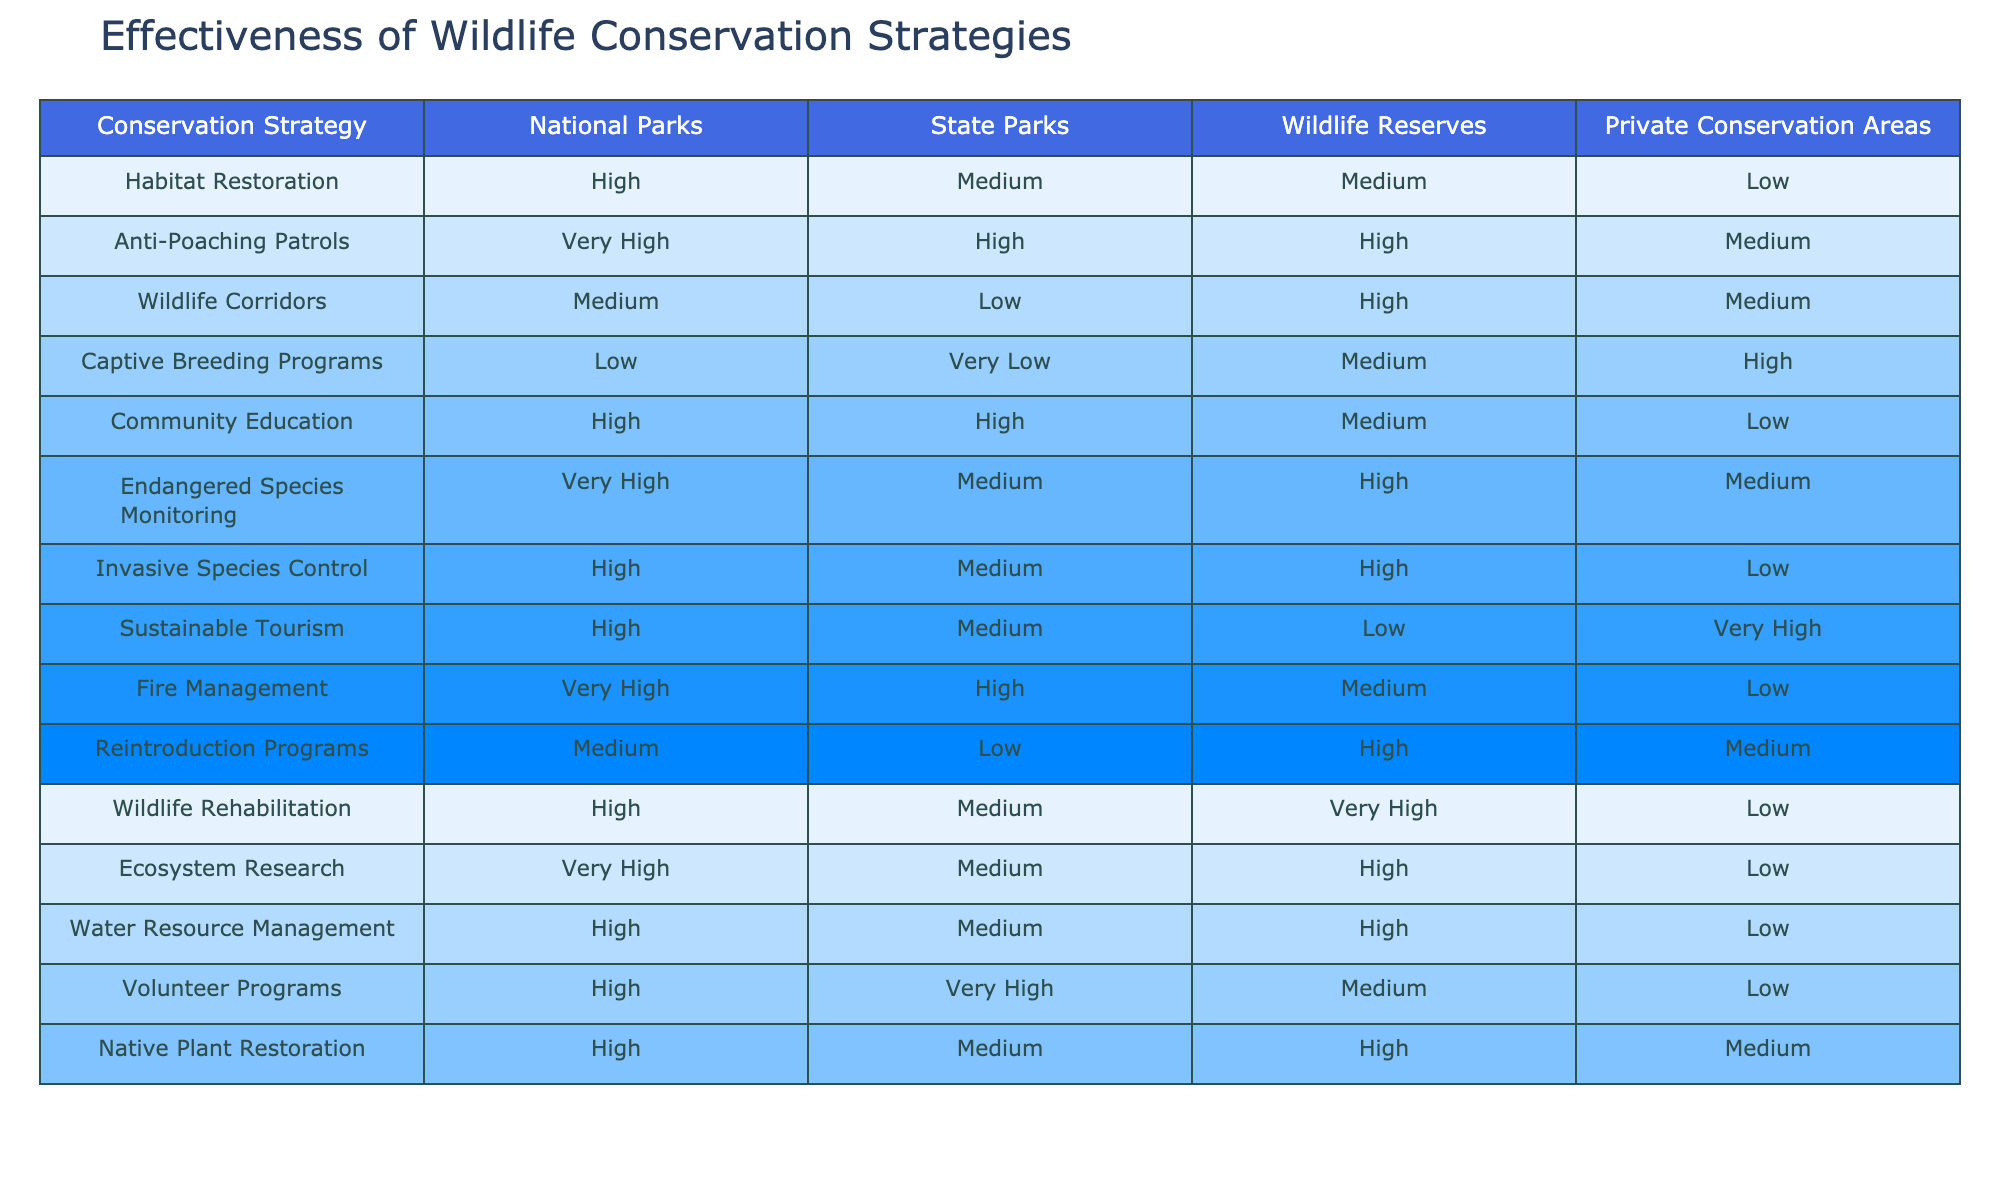What is the effectiveness of habitat restoration in wildlife reserves? The table shows that habitat restoration is rated as Medium in wildlife reserves.
Answer: Medium Which conservation strategy has the highest effectiveness in national parks? The effectiveness ratings indicate that Anti-Poaching Patrols have the highest effectiveness with a rating of Very High.
Answer: Very High How does the effectiveness of community education compare between state parks and wildlife reserves? Community education effectiveness is High in state parks and Medium in wildlife reserves, indicating greater effectiveness in state parks.
Answer: Higher in state parks Are captive breeding programs effective in national parks? The table indicates that the effectiveness of captive breeding programs in national parks is rated as Low.
Answer: No Calculate the average effectiveness rating for reintroduction programs across all park types. The ratings for reintroduction programs are Medium for national parks and private conservation areas, Low for state parks, and High for wildlife reserves. To find the average, we assign numerical values: Very Low (1), Low (2), Medium (3), High (4), Very High (5). This gives us (3 + 2 + 4 + 3)/4 = 3. So the average rating is Medium.
Answer: Medium Is there a conservation strategy that has Very High effectiveness across all park types? Looking at the table, there is no conservation strategy rated as Very High in all park types, indicating that strategies have varying effectiveness.
Answer: No Which park type has the lowest effectiveness for sustainable tourism? The sustainable tourism effectiveness ratings show that wildlife reserves have the lowest effectiveness, rated as Low.
Answer: Wildlife Reserves What is the difference in effectiveness between the highest and lowest rated conservation strategies in private conservation areas? In private conservation areas, the highest rated strategy is Captive Breeding Programs (High) and the lowest is Habitat Restoration (Low). The difference in effectiveness ratings is High (4) - Low (2) = 2, indicating a significant gap.
Answer: 2 Do endangered species monitoring strategies show high effectiveness in state parks? The table indicates that endangered species monitoring is rated as Medium in state parks, which does not fall under the category of high effectiveness.
Answer: No 